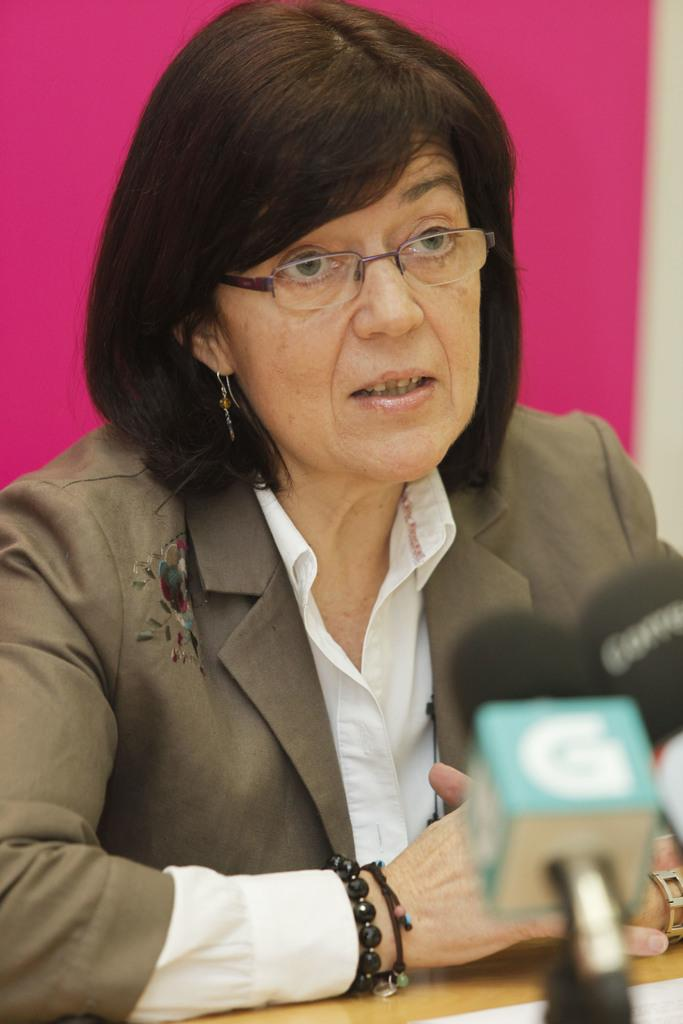Who is the main subject in the image? There is a woman in the image. What is the woman wearing on her face? The woman is wearing specs. What type of jewelry is the woman wearing? The woman is wearing bracelets. What is the furniture piece in the image? There is a table in the image. What equipment is in front of the woman? There are mics in front of the woman. What color is the wall visible in the background? There is a pink wall in the background of the image. What type of lunch is the woman eating in the image? There is no lunch visible in the image; the woman is not eating. Who is the woman's friend in the image? There is no friend visible in the image; the woman is alone. 